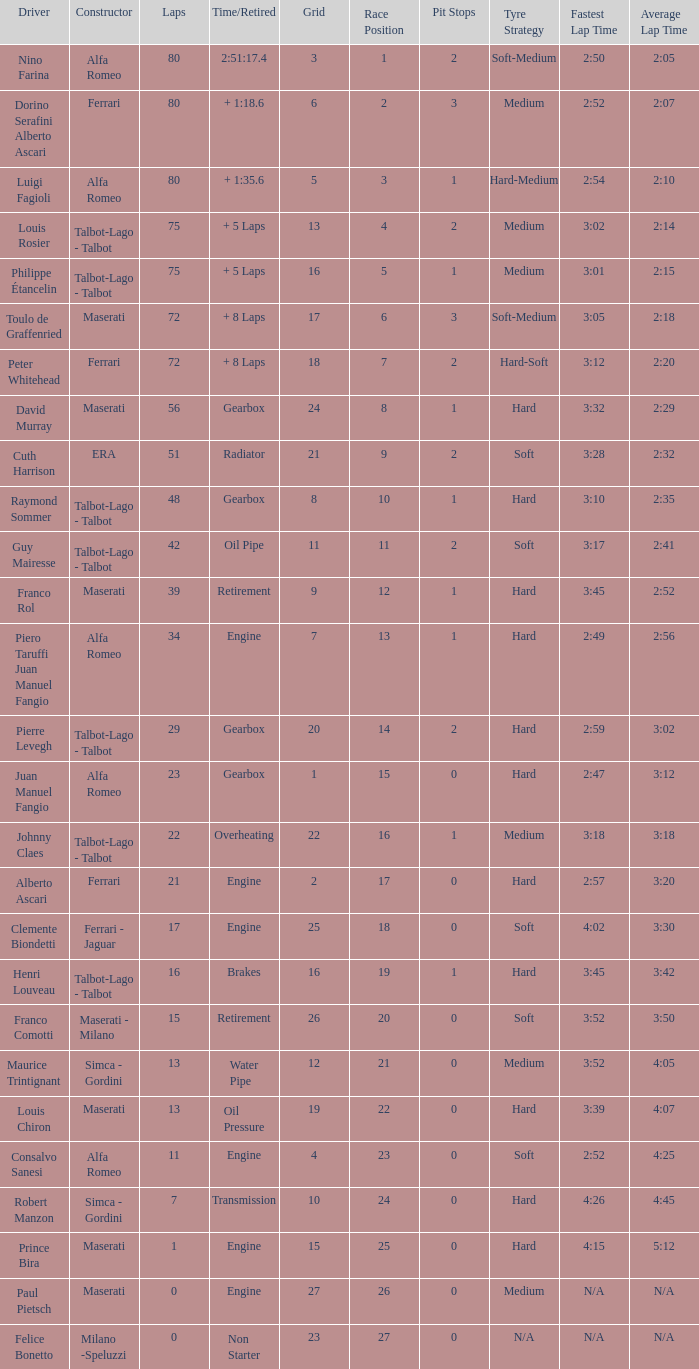When the driver is Juan Manuel Fangio and laps is less than 39, what is the highest grid? 1.0. 